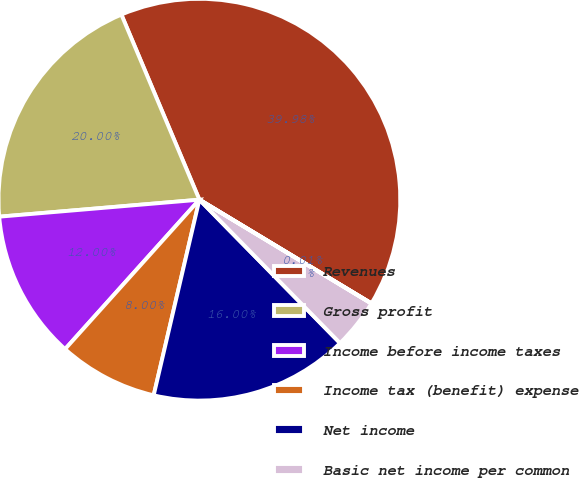<chart> <loc_0><loc_0><loc_500><loc_500><pie_chart><fcel>Revenues<fcel>Gross profit<fcel>Income before income taxes<fcel>Income tax (benefit) expense<fcel>Net income<fcel>Basic net income per common<fcel>Diluted net income per common<nl><fcel>39.98%<fcel>20.0%<fcel>12.0%<fcel>8.0%<fcel>16.0%<fcel>4.01%<fcel>0.01%<nl></chart> 